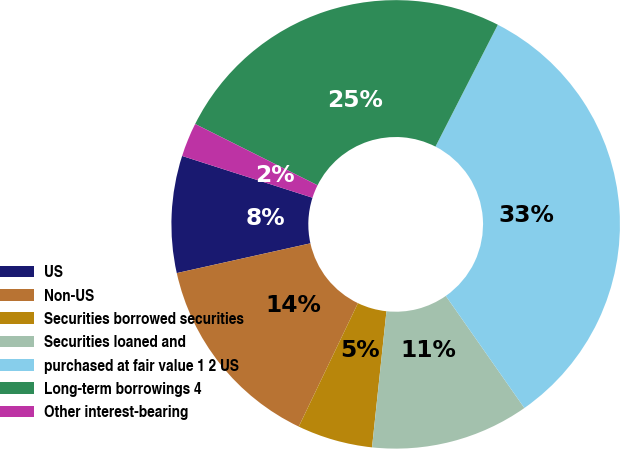Convert chart to OTSL. <chart><loc_0><loc_0><loc_500><loc_500><pie_chart><fcel>US<fcel>Non-US<fcel>Securities borrowed securities<fcel>Securities loaned and<fcel>purchased at fair value 1 2 US<fcel>Long-term borrowings 4<fcel>Other interest-bearing<nl><fcel>8.42%<fcel>14.4%<fcel>5.43%<fcel>11.41%<fcel>32.74%<fcel>25.14%<fcel>2.45%<nl></chart> 